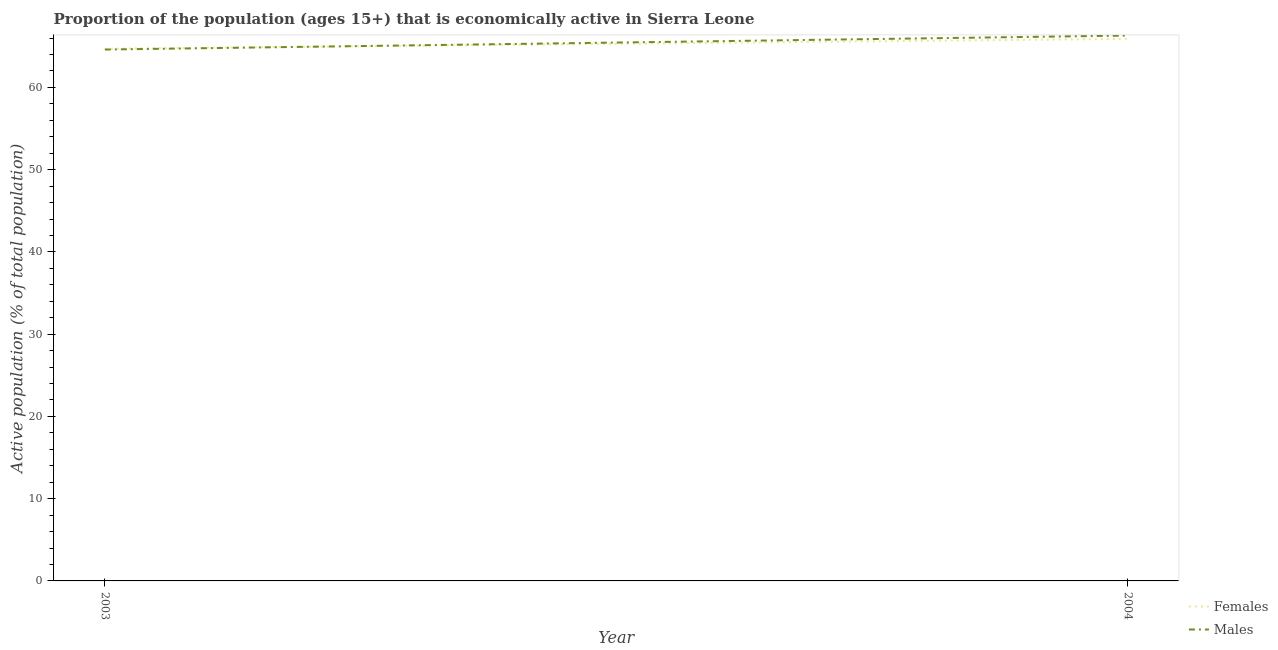How many different coloured lines are there?
Your answer should be very brief. 2. Is the number of lines equal to the number of legend labels?
Your response must be concise. Yes. What is the percentage of economically active female population in 2004?
Make the answer very short. 65.9. Across all years, what is the maximum percentage of economically active female population?
Your answer should be very brief. 65.9. Across all years, what is the minimum percentage of economically active female population?
Your answer should be compact. 64.7. In which year was the percentage of economically active male population maximum?
Provide a short and direct response. 2004. What is the total percentage of economically active male population in the graph?
Your answer should be very brief. 130.9. What is the difference between the percentage of economically active male population in 2003 and that in 2004?
Make the answer very short. -1.7. What is the difference between the percentage of economically active female population in 2004 and the percentage of economically active male population in 2003?
Make the answer very short. 1.3. What is the average percentage of economically active female population per year?
Your answer should be very brief. 65.3. In the year 2003, what is the difference between the percentage of economically active female population and percentage of economically active male population?
Give a very brief answer. 0.1. In how many years, is the percentage of economically active male population greater than 48 %?
Your response must be concise. 2. What is the ratio of the percentage of economically active male population in 2003 to that in 2004?
Ensure brevity in your answer.  0.97. In how many years, is the percentage of economically active female population greater than the average percentage of economically active female population taken over all years?
Provide a succinct answer. 1. Does the percentage of economically active female population monotonically increase over the years?
Offer a very short reply. Yes. Is the percentage of economically active female population strictly greater than the percentage of economically active male population over the years?
Provide a succinct answer. No. How many years are there in the graph?
Ensure brevity in your answer.  2. Are the values on the major ticks of Y-axis written in scientific E-notation?
Provide a succinct answer. No. Does the graph contain grids?
Offer a very short reply. No. Where does the legend appear in the graph?
Offer a terse response. Bottom right. How many legend labels are there?
Your answer should be compact. 2. How are the legend labels stacked?
Give a very brief answer. Vertical. What is the title of the graph?
Ensure brevity in your answer.  Proportion of the population (ages 15+) that is economically active in Sierra Leone. What is the label or title of the X-axis?
Give a very brief answer. Year. What is the label or title of the Y-axis?
Make the answer very short. Active population (% of total population). What is the Active population (% of total population) in Females in 2003?
Keep it short and to the point. 64.7. What is the Active population (% of total population) of Males in 2003?
Provide a succinct answer. 64.6. What is the Active population (% of total population) of Females in 2004?
Provide a short and direct response. 65.9. What is the Active population (% of total population) in Males in 2004?
Offer a terse response. 66.3. Across all years, what is the maximum Active population (% of total population) of Females?
Make the answer very short. 65.9. Across all years, what is the maximum Active population (% of total population) of Males?
Your answer should be compact. 66.3. Across all years, what is the minimum Active population (% of total population) of Females?
Give a very brief answer. 64.7. Across all years, what is the minimum Active population (% of total population) of Males?
Your response must be concise. 64.6. What is the total Active population (% of total population) of Females in the graph?
Offer a terse response. 130.6. What is the total Active population (% of total population) in Males in the graph?
Offer a terse response. 130.9. What is the difference between the Active population (% of total population) in Females in 2003 and the Active population (% of total population) in Males in 2004?
Your answer should be very brief. -1.6. What is the average Active population (% of total population) of Females per year?
Ensure brevity in your answer.  65.3. What is the average Active population (% of total population) in Males per year?
Offer a very short reply. 65.45. In the year 2004, what is the difference between the Active population (% of total population) in Females and Active population (% of total population) in Males?
Your answer should be compact. -0.4. What is the ratio of the Active population (% of total population) of Females in 2003 to that in 2004?
Your answer should be very brief. 0.98. What is the ratio of the Active population (% of total population) of Males in 2003 to that in 2004?
Keep it short and to the point. 0.97. What is the difference between the highest and the second highest Active population (% of total population) in Males?
Make the answer very short. 1.7. What is the difference between the highest and the lowest Active population (% of total population) of Females?
Provide a succinct answer. 1.2. 